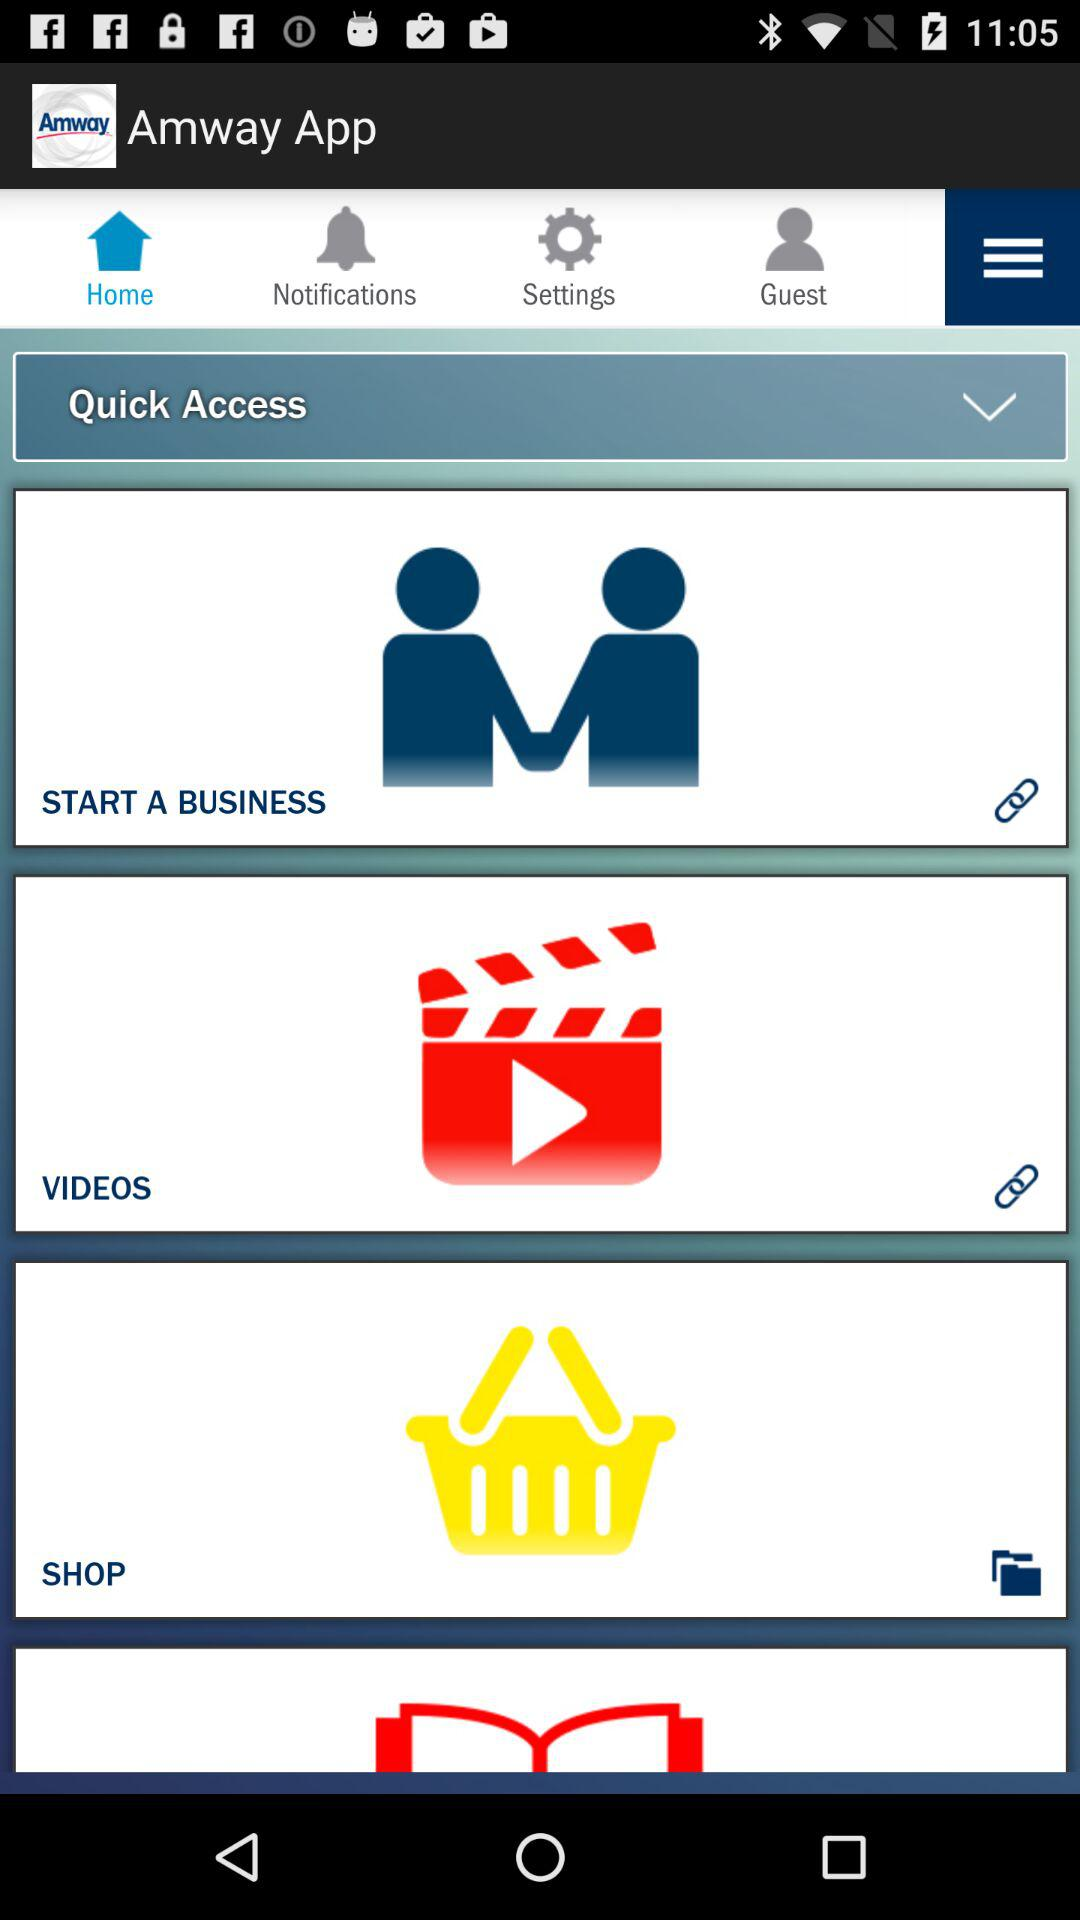Which tab is selected? The selected tab is "Home". 